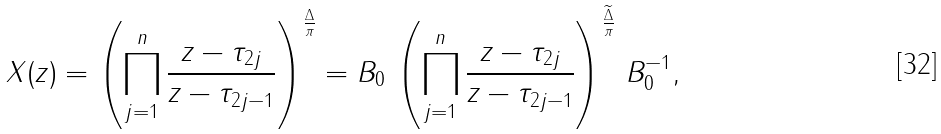Convert formula to latex. <formula><loc_0><loc_0><loc_500><loc_500>X ( z ) = \left ( \prod _ { j = 1 } ^ { n } \frac { z - \tau _ { 2 j } } { z - \tau _ { 2 j - 1 } } \right ) ^ { \frac { \Delta } { \pi } } = B _ { 0 } \, \left ( \prod _ { j = 1 } ^ { n } \frac { z - \tau _ { 2 j } } { z - \tau _ { 2 j - 1 } } \right ) ^ { \frac { \widetilde { \Delta } } { \pi } } \, B _ { 0 } ^ { - 1 } ,</formula> 